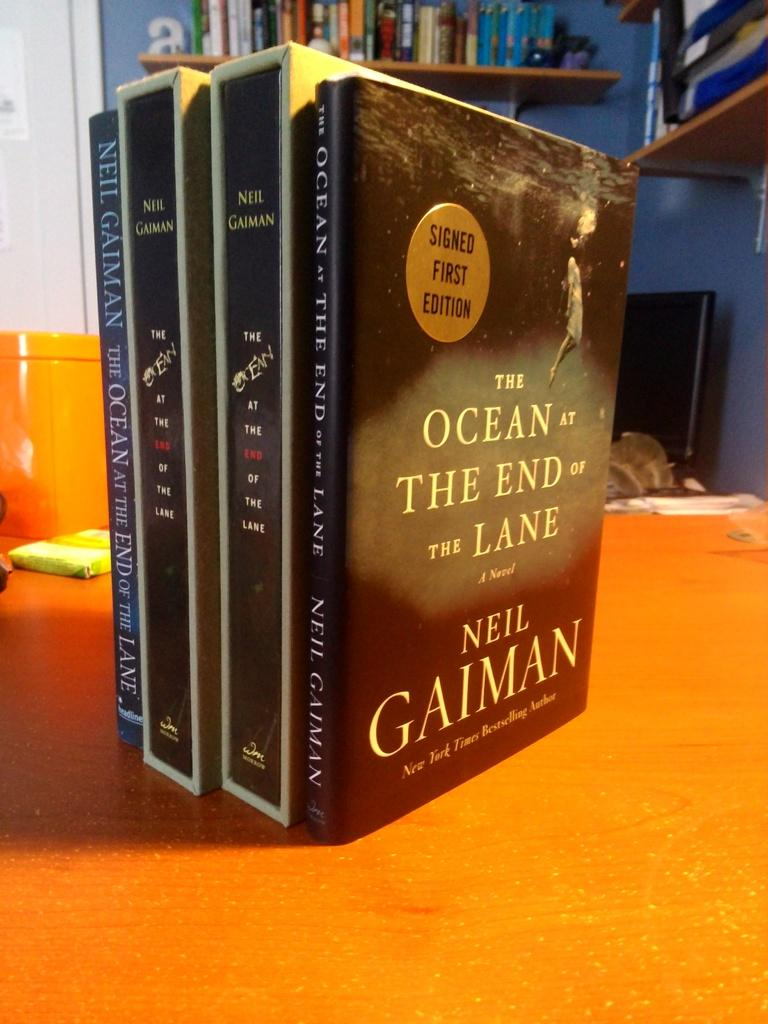Provide a one-sentence caption for the provided image. table with four neil gaiman books standing upright on it. 